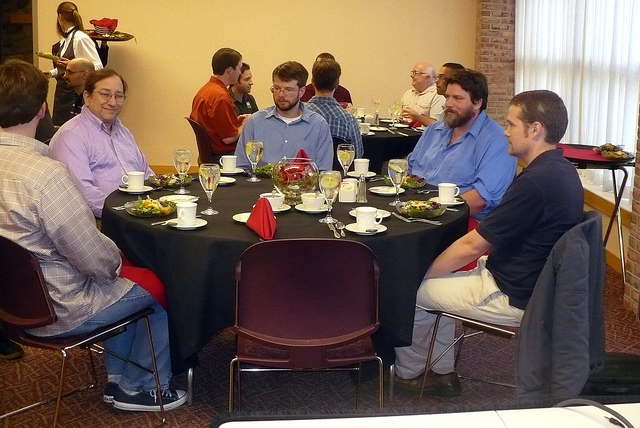Are there any distinctive items on the table that indicate the type of meal being served? The table is set with what appears to be salad plates and filled water glasses, suggesting the meal is likely to include a formal course service, possibly starting with a light appetizer or salad. 